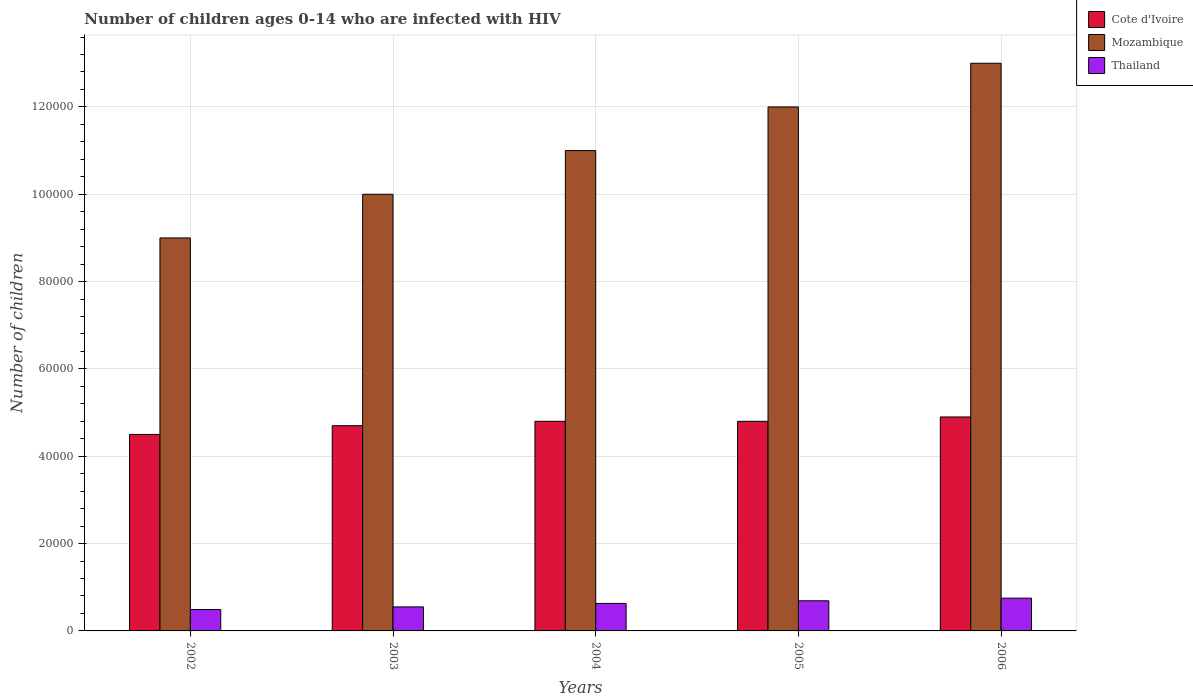Are the number of bars on each tick of the X-axis equal?
Provide a succinct answer. Yes. How many bars are there on the 3rd tick from the left?
Ensure brevity in your answer.  3. How many bars are there on the 4th tick from the right?
Make the answer very short. 3. What is the label of the 2nd group of bars from the left?
Your answer should be compact. 2003. What is the number of HIV infected children in Thailand in 2003?
Ensure brevity in your answer.  5500. Across all years, what is the maximum number of HIV infected children in Mozambique?
Keep it short and to the point. 1.30e+05. Across all years, what is the minimum number of HIV infected children in Cote d'Ivoire?
Provide a short and direct response. 4.50e+04. In which year was the number of HIV infected children in Cote d'Ivoire maximum?
Keep it short and to the point. 2006. What is the total number of HIV infected children in Thailand in the graph?
Give a very brief answer. 3.11e+04. What is the difference between the number of HIV infected children in Thailand in 2003 and that in 2006?
Provide a short and direct response. -2000. What is the difference between the number of HIV infected children in Thailand in 2005 and the number of HIV infected children in Cote d'Ivoire in 2002?
Keep it short and to the point. -3.81e+04. What is the average number of HIV infected children in Thailand per year?
Offer a very short reply. 6220. In the year 2006, what is the difference between the number of HIV infected children in Thailand and number of HIV infected children in Cote d'Ivoire?
Ensure brevity in your answer.  -4.15e+04. What is the ratio of the number of HIV infected children in Mozambique in 2002 to that in 2004?
Offer a terse response. 0.82. Is the number of HIV infected children in Thailand in 2002 less than that in 2006?
Give a very brief answer. Yes. What is the difference between the highest and the lowest number of HIV infected children in Thailand?
Give a very brief answer. 2600. What does the 2nd bar from the left in 2004 represents?
Your response must be concise. Mozambique. What does the 2nd bar from the right in 2003 represents?
Keep it short and to the point. Mozambique. Are the values on the major ticks of Y-axis written in scientific E-notation?
Provide a short and direct response. No. Does the graph contain grids?
Your answer should be compact. Yes. What is the title of the graph?
Provide a succinct answer. Number of children ages 0-14 who are infected with HIV. What is the label or title of the Y-axis?
Ensure brevity in your answer.  Number of children. What is the Number of children in Cote d'Ivoire in 2002?
Your answer should be compact. 4.50e+04. What is the Number of children in Mozambique in 2002?
Give a very brief answer. 9.00e+04. What is the Number of children in Thailand in 2002?
Keep it short and to the point. 4900. What is the Number of children in Cote d'Ivoire in 2003?
Give a very brief answer. 4.70e+04. What is the Number of children of Thailand in 2003?
Offer a very short reply. 5500. What is the Number of children in Cote d'Ivoire in 2004?
Keep it short and to the point. 4.80e+04. What is the Number of children in Thailand in 2004?
Your response must be concise. 6300. What is the Number of children of Cote d'Ivoire in 2005?
Provide a short and direct response. 4.80e+04. What is the Number of children of Thailand in 2005?
Ensure brevity in your answer.  6900. What is the Number of children of Cote d'Ivoire in 2006?
Offer a terse response. 4.90e+04. What is the Number of children in Thailand in 2006?
Offer a terse response. 7500. Across all years, what is the maximum Number of children in Cote d'Ivoire?
Give a very brief answer. 4.90e+04. Across all years, what is the maximum Number of children of Mozambique?
Your answer should be compact. 1.30e+05. Across all years, what is the maximum Number of children in Thailand?
Make the answer very short. 7500. Across all years, what is the minimum Number of children of Cote d'Ivoire?
Make the answer very short. 4.50e+04. Across all years, what is the minimum Number of children of Thailand?
Make the answer very short. 4900. What is the total Number of children of Cote d'Ivoire in the graph?
Give a very brief answer. 2.37e+05. What is the total Number of children in Mozambique in the graph?
Ensure brevity in your answer.  5.50e+05. What is the total Number of children in Thailand in the graph?
Your answer should be very brief. 3.11e+04. What is the difference between the Number of children in Cote d'Ivoire in 2002 and that in 2003?
Your answer should be compact. -2000. What is the difference between the Number of children in Thailand in 2002 and that in 2003?
Ensure brevity in your answer.  -600. What is the difference between the Number of children in Cote d'Ivoire in 2002 and that in 2004?
Offer a terse response. -3000. What is the difference between the Number of children in Mozambique in 2002 and that in 2004?
Make the answer very short. -2.00e+04. What is the difference between the Number of children of Thailand in 2002 and that in 2004?
Provide a succinct answer. -1400. What is the difference between the Number of children of Cote d'Ivoire in 2002 and that in 2005?
Provide a succinct answer. -3000. What is the difference between the Number of children in Thailand in 2002 and that in 2005?
Ensure brevity in your answer.  -2000. What is the difference between the Number of children of Cote d'Ivoire in 2002 and that in 2006?
Ensure brevity in your answer.  -4000. What is the difference between the Number of children of Mozambique in 2002 and that in 2006?
Ensure brevity in your answer.  -4.00e+04. What is the difference between the Number of children in Thailand in 2002 and that in 2006?
Ensure brevity in your answer.  -2600. What is the difference between the Number of children of Cote d'Ivoire in 2003 and that in 2004?
Your response must be concise. -1000. What is the difference between the Number of children of Mozambique in 2003 and that in 2004?
Give a very brief answer. -10000. What is the difference between the Number of children in Thailand in 2003 and that in 2004?
Keep it short and to the point. -800. What is the difference between the Number of children in Cote d'Ivoire in 2003 and that in 2005?
Your response must be concise. -1000. What is the difference between the Number of children of Mozambique in 2003 and that in 2005?
Ensure brevity in your answer.  -2.00e+04. What is the difference between the Number of children of Thailand in 2003 and that in 2005?
Your answer should be very brief. -1400. What is the difference between the Number of children of Cote d'Ivoire in 2003 and that in 2006?
Keep it short and to the point. -2000. What is the difference between the Number of children in Thailand in 2003 and that in 2006?
Provide a short and direct response. -2000. What is the difference between the Number of children in Cote d'Ivoire in 2004 and that in 2005?
Offer a terse response. 0. What is the difference between the Number of children in Mozambique in 2004 and that in 2005?
Provide a succinct answer. -10000. What is the difference between the Number of children in Thailand in 2004 and that in 2005?
Keep it short and to the point. -600. What is the difference between the Number of children in Cote d'Ivoire in 2004 and that in 2006?
Your answer should be very brief. -1000. What is the difference between the Number of children of Thailand in 2004 and that in 2006?
Ensure brevity in your answer.  -1200. What is the difference between the Number of children in Cote d'Ivoire in 2005 and that in 2006?
Your answer should be compact. -1000. What is the difference between the Number of children of Thailand in 2005 and that in 2006?
Keep it short and to the point. -600. What is the difference between the Number of children in Cote d'Ivoire in 2002 and the Number of children in Mozambique in 2003?
Keep it short and to the point. -5.50e+04. What is the difference between the Number of children in Cote d'Ivoire in 2002 and the Number of children in Thailand in 2003?
Your response must be concise. 3.95e+04. What is the difference between the Number of children of Mozambique in 2002 and the Number of children of Thailand in 2003?
Ensure brevity in your answer.  8.45e+04. What is the difference between the Number of children in Cote d'Ivoire in 2002 and the Number of children in Mozambique in 2004?
Make the answer very short. -6.50e+04. What is the difference between the Number of children in Cote d'Ivoire in 2002 and the Number of children in Thailand in 2004?
Give a very brief answer. 3.87e+04. What is the difference between the Number of children of Mozambique in 2002 and the Number of children of Thailand in 2004?
Your answer should be compact. 8.37e+04. What is the difference between the Number of children in Cote d'Ivoire in 2002 and the Number of children in Mozambique in 2005?
Ensure brevity in your answer.  -7.50e+04. What is the difference between the Number of children in Cote d'Ivoire in 2002 and the Number of children in Thailand in 2005?
Your response must be concise. 3.81e+04. What is the difference between the Number of children in Mozambique in 2002 and the Number of children in Thailand in 2005?
Offer a very short reply. 8.31e+04. What is the difference between the Number of children in Cote d'Ivoire in 2002 and the Number of children in Mozambique in 2006?
Keep it short and to the point. -8.50e+04. What is the difference between the Number of children of Cote d'Ivoire in 2002 and the Number of children of Thailand in 2006?
Make the answer very short. 3.75e+04. What is the difference between the Number of children in Mozambique in 2002 and the Number of children in Thailand in 2006?
Offer a very short reply. 8.25e+04. What is the difference between the Number of children in Cote d'Ivoire in 2003 and the Number of children in Mozambique in 2004?
Your answer should be very brief. -6.30e+04. What is the difference between the Number of children in Cote d'Ivoire in 2003 and the Number of children in Thailand in 2004?
Keep it short and to the point. 4.07e+04. What is the difference between the Number of children of Mozambique in 2003 and the Number of children of Thailand in 2004?
Your answer should be compact. 9.37e+04. What is the difference between the Number of children in Cote d'Ivoire in 2003 and the Number of children in Mozambique in 2005?
Your answer should be compact. -7.30e+04. What is the difference between the Number of children of Cote d'Ivoire in 2003 and the Number of children of Thailand in 2005?
Your answer should be compact. 4.01e+04. What is the difference between the Number of children in Mozambique in 2003 and the Number of children in Thailand in 2005?
Offer a terse response. 9.31e+04. What is the difference between the Number of children in Cote d'Ivoire in 2003 and the Number of children in Mozambique in 2006?
Offer a terse response. -8.30e+04. What is the difference between the Number of children of Cote d'Ivoire in 2003 and the Number of children of Thailand in 2006?
Make the answer very short. 3.95e+04. What is the difference between the Number of children of Mozambique in 2003 and the Number of children of Thailand in 2006?
Offer a terse response. 9.25e+04. What is the difference between the Number of children of Cote d'Ivoire in 2004 and the Number of children of Mozambique in 2005?
Your answer should be compact. -7.20e+04. What is the difference between the Number of children of Cote d'Ivoire in 2004 and the Number of children of Thailand in 2005?
Your answer should be very brief. 4.11e+04. What is the difference between the Number of children of Mozambique in 2004 and the Number of children of Thailand in 2005?
Ensure brevity in your answer.  1.03e+05. What is the difference between the Number of children of Cote d'Ivoire in 2004 and the Number of children of Mozambique in 2006?
Ensure brevity in your answer.  -8.20e+04. What is the difference between the Number of children in Cote d'Ivoire in 2004 and the Number of children in Thailand in 2006?
Your answer should be very brief. 4.05e+04. What is the difference between the Number of children in Mozambique in 2004 and the Number of children in Thailand in 2006?
Make the answer very short. 1.02e+05. What is the difference between the Number of children in Cote d'Ivoire in 2005 and the Number of children in Mozambique in 2006?
Your response must be concise. -8.20e+04. What is the difference between the Number of children in Cote d'Ivoire in 2005 and the Number of children in Thailand in 2006?
Give a very brief answer. 4.05e+04. What is the difference between the Number of children in Mozambique in 2005 and the Number of children in Thailand in 2006?
Your response must be concise. 1.12e+05. What is the average Number of children in Cote d'Ivoire per year?
Your answer should be very brief. 4.74e+04. What is the average Number of children in Thailand per year?
Keep it short and to the point. 6220. In the year 2002, what is the difference between the Number of children in Cote d'Ivoire and Number of children in Mozambique?
Provide a short and direct response. -4.50e+04. In the year 2002, what is the difference between the Number of children of Cote d'Ivoire and Number of children of Thailand?
Your response must be concise. 4.01e+04. In the year 2002, what is the difference between the Number of children of Mozambique and Number of children of Thailand?
Provide a short and direct response. 8.51e+04. In the year 2003, what is the difference between the Number of children of Cote d'Ivoire and Number of children of Mozambique?
Provide a succinct answer. -5.30e+04. In the year 2003, what is the difference between the Number of children in Cote d'Ivoire and Number of children in Thailand?
Ensure brevity in your answer.  4.15e+04. In the year 2003, what is the difference between the Number of children in Mozambique and Number of children in Thailand?
Give a very brief answer. 9.45e+04. In the year 2004, what is the difference between the Number of children in Cote d'Ivoire and Number of children in Mozambique?
Give a very brief answer. -6.20e+04. In the year 2004, what is the difference between the Number of children in Cote d'Ivoire and Number of children in Thailand?
Offer a very short reply. 4.17e+04. In the year 2004, what is the difference between the Number of children of Mozambique and Number of children of Thailand?
Provide a short and direct response. 1.04e+05. In the year 2005, what is the difference between the Number of children of Cote d'Ivoire and Number of children of Mozambique?
Offer a terse response. -7.20e+04. In the year 2005, what is the difference between the Number of children in Cote d'Ivoire and Number of children in Thailand?
Ensure brevity in your answer.  4.11e+04. In the year 2005, what is the difference between the Number of children of Mozambique and Number of children of Thailand?
Your response must be concise. 1.13e+05. In the year 2006, what is the difference between the Number of children of Cote d'Ivoire and Number of children of Mozambique?
Keep it short and to the point. -8.10e+04. In the year 2006, what is the difference between the Number of children of Cote d'Ivoire and Number of children of Thailand?
Provide a succinct answer. 4.15e+04. In the year 2006, what is the difference between the Number of children in Mozambique and Number of children in Thailand?
Offer a very short reply. 1.22e+05. What is the ratio of the Number of children in Cote d'Ivoire in 2002 to that in 2003?
Give a very brief answer. 0.96. What is the ratio of the Number of children of Thailand in 2002 to that in 2003?
Your response must be concise. 0.89. What is the ratio of the Number of children in Cote d'Ivoire in 2002 to that in 2004?
Keep it short and to the point. 0.94. What is the ratio of the Number of children of Mozambique in 2002 to that in 2004?
Your answer should be very brief. 0.82. What is the ratio of the Number of children of Thailand in 2002 to that in 2004?
Your answer should be very brief. 0.78. What is the ratio of the Number of children in Cote d'Ivoire in 2002 to that in 2005?
Offer a very short reply. 0.94. What is the ratio of the Number of children of Mozambique in 2002 to that in 2005?
Your answer should be compact. 0.75. What is the ratio of the Number of children of Thailand in 2002 to that in 2005?
Your answer should be compact. 0.71. What is the ratio of the Number of children of Cote d'Ivoire in 2002 to that in 2006?
Make the answer very short. 0.92. What is the ratio of the Number of children in Mozambique in 2002 to that in 2006?
Give a very brief answer. 0.69. What is the ratio of the Number of children in Thailand in 2002 to that in 2006?
Your answer should be very brief. 0.65. What is the ratio of the Number of children of Cote d'Ivoire in 2003 to that in 2004?
Provide a short and direct response. 0.98. What is the ratio of the Number of children in Mozambique in 2003 to that in 2004?
Your answer should be compact. 0.91. What is the ratio of the Number of children in Thailand in 2003 to that in 2004?
Make the answer very short. 0.87. What is the ratio of the Number of children of Cote d'Ivoire in 2003 to that in 2005?
Offer a very short reply. 0.98. What is the ratio of the Number of children in Mozambique in 2003 to that in 2005?
Keep it short and to the point. 0.83. What is the ratio of the Number of children of Thailand in 2003 to that in 2005?
Your response must be concise. 0.8. What is the ratio of the Number of children of Cote d'Ivoire in 2003 to that in 2006?
Offer a terse response. 0.96. What is the ratio of the Number of children in Mozambique in 2003 to that in 2006?
Your answer should be very brief. 0.77. What is the ratio of the Number of children of Thailand in 2003 to that in 2006?
Give a very brief answer. 0.73. What is the ratio of the Number of children of Thailand in 2004 to that in 2005?
Your response must be concise. 0.91. What is the ratio of the Number of children in Cote d'Ivoire in 2004 to that in 2006?
Offer a very short reply. 0.98. What is the ratio of the Number of children in Mozambique in 2004 to that in 2006?
Provide a short and direct response. 0.85. What is the ratio of the Number of children in Thailand in 2004 to that in 2006?
Ensure brevity in your answer.  0.84. What is the ratio of the Number of children in Cote d'Ivoire in 2005 to that in 2006?
Offer a very short reply. 0.98. What is the difference between the highest and the second highest Number of children in Thailand?
Provide a short and direct response. 600. What is the difference between the highest and the lowest Number of children of Cote d'Ivoire?
Your answer should be very brief. 4000. What is the difference between the highest and the lowest Number of children in Mozambique?
Make the answer very short. 4.00e+04. What is the difference between the highest and the lowest Number of children in Thailand?
Give a very brief answer. 2600. 